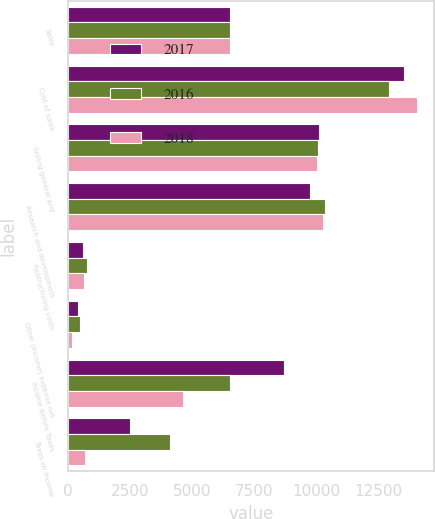Convert chart to OTSL. <chart><loc_0><loc_0><loc_500><loc_500><stacked_bar_chart><ecel><fcel>Sales<fcel>Cost of sales<fcel>Selling general and<fcel>Research and development<fcel>Restructuring costs<fcel>Other (income) expense net<fcel>Income Before Taxes<fcel>Taxes on Income<nl><fcel>2017<fcel>6521<fcel>13509<fcel>10102<fcel>9752<fcel>632<fcel>402<fcel>8701<fcel>2508<nl><fcel>2016<fcel>6521<fcel>12912<fcel>10074<fcel>10339<fcel>776<fcel>500<fcel>6521<fcel>4103<nl><fcel>2018<fcel>6521<fcel>14030<fcel>10017<fcel>10261<fcel>651<fcel>189<fcel>4659<fcel>718<nl></chart> 